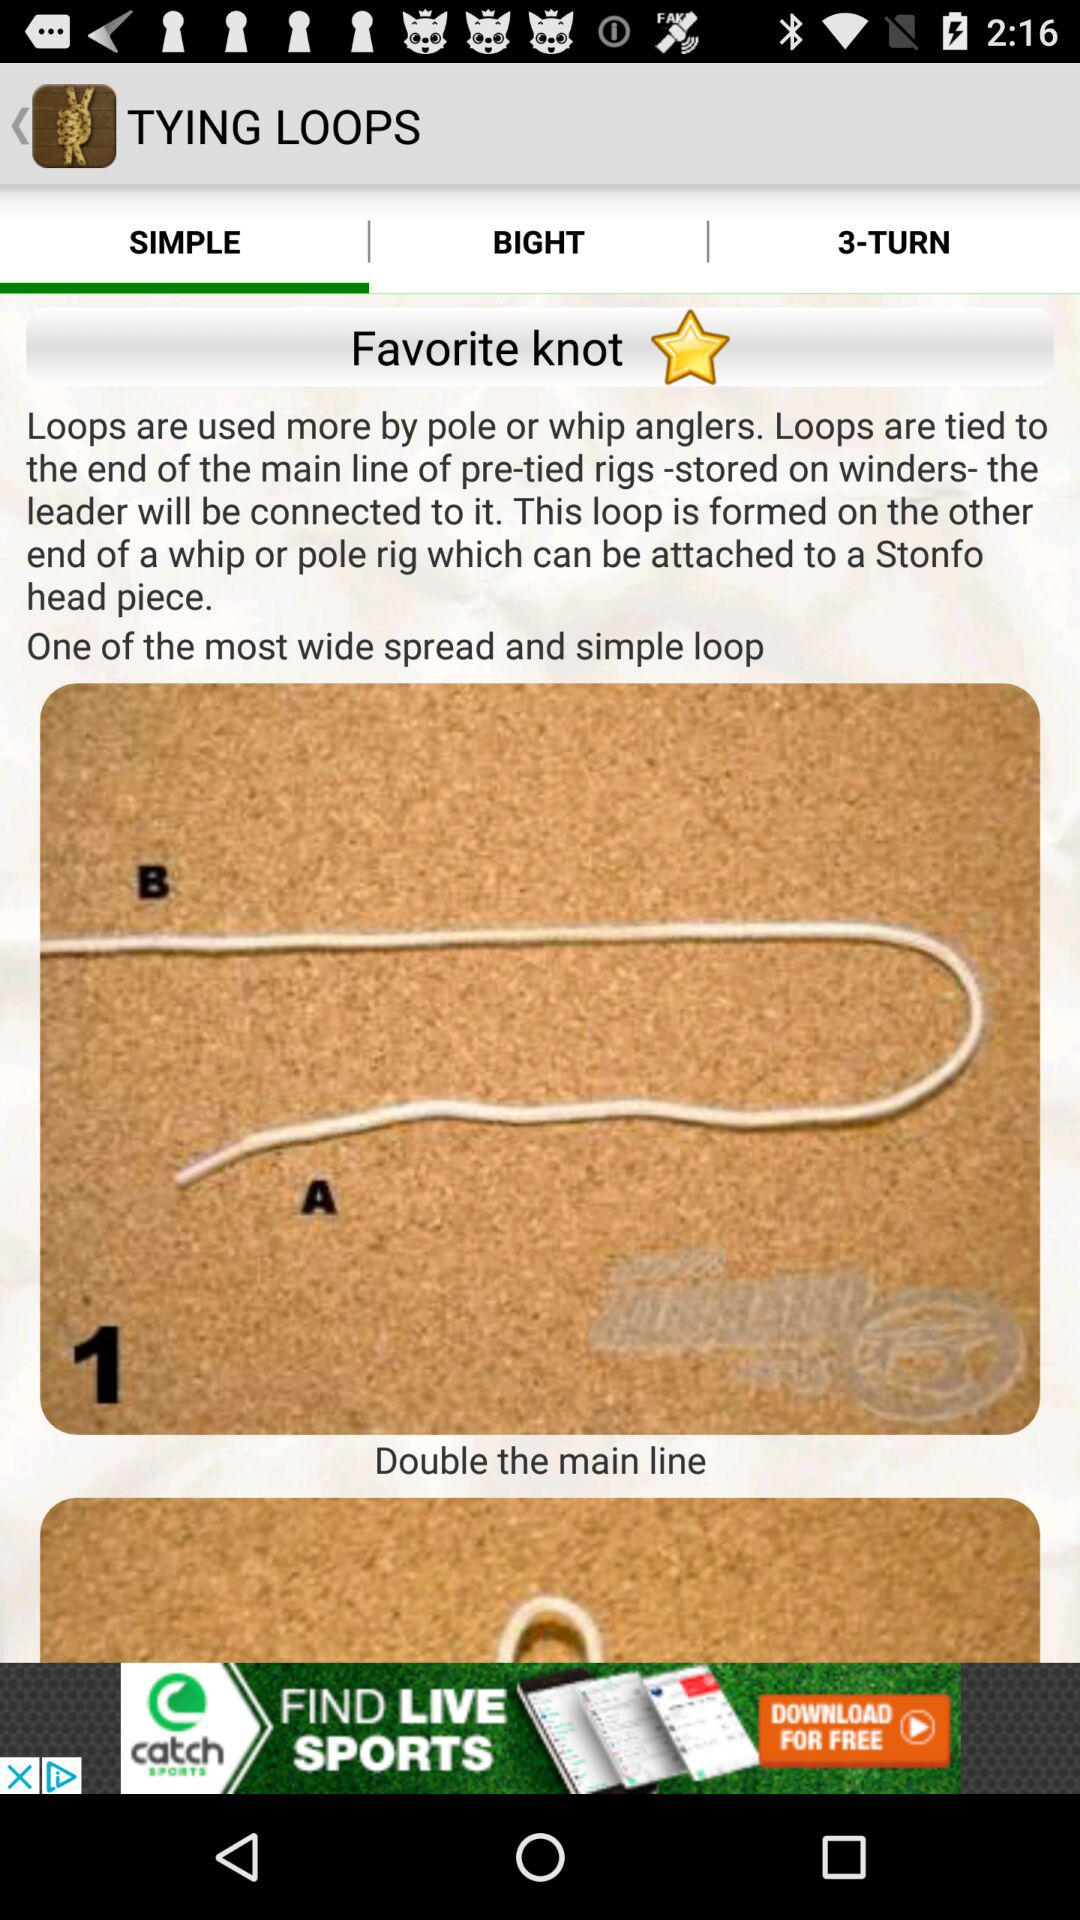Which tab is selected? The selected tab is "SIMPLE". 